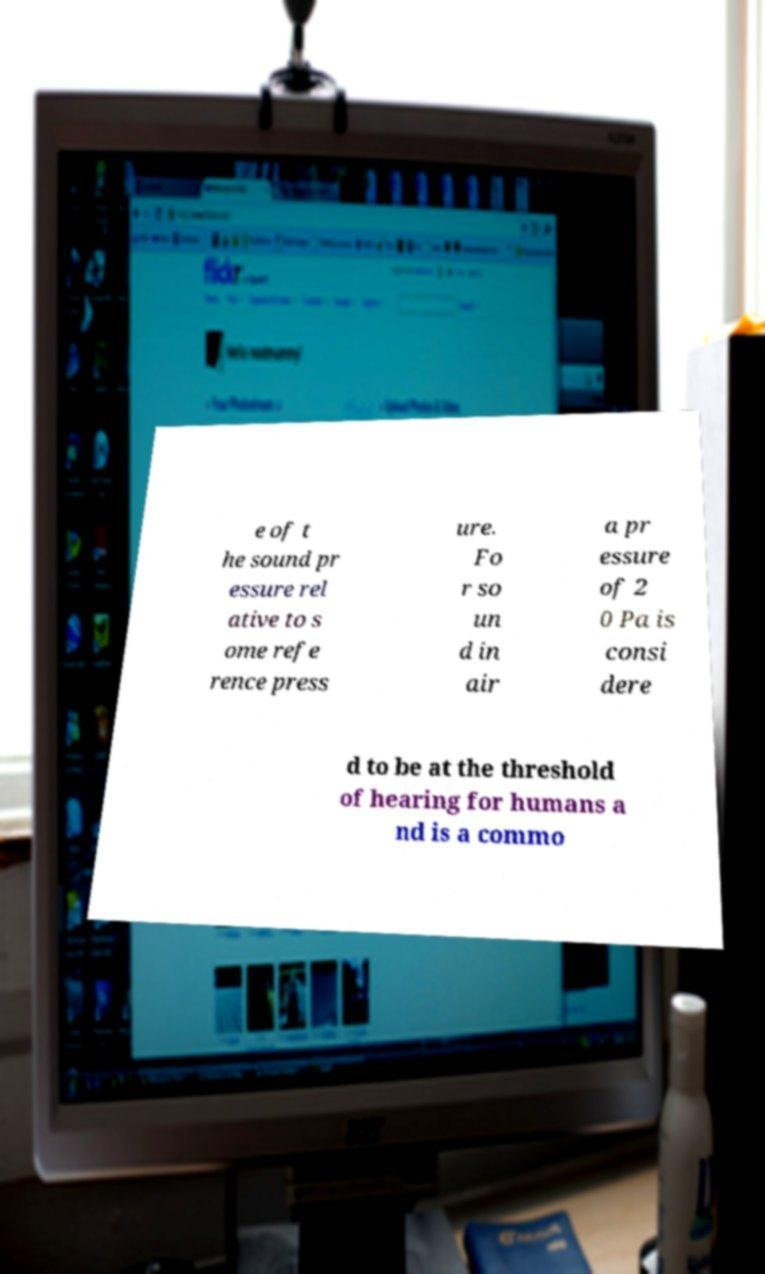I need the written content from this picture converted into text. Can you do that? e of t he sound pr essure rel ative to s ome refe rence press ure. Fo r so un d in air a pr essure of 2 0 Pa is consi dere d to be at the threshold of hearing for humans a nd is a commo 